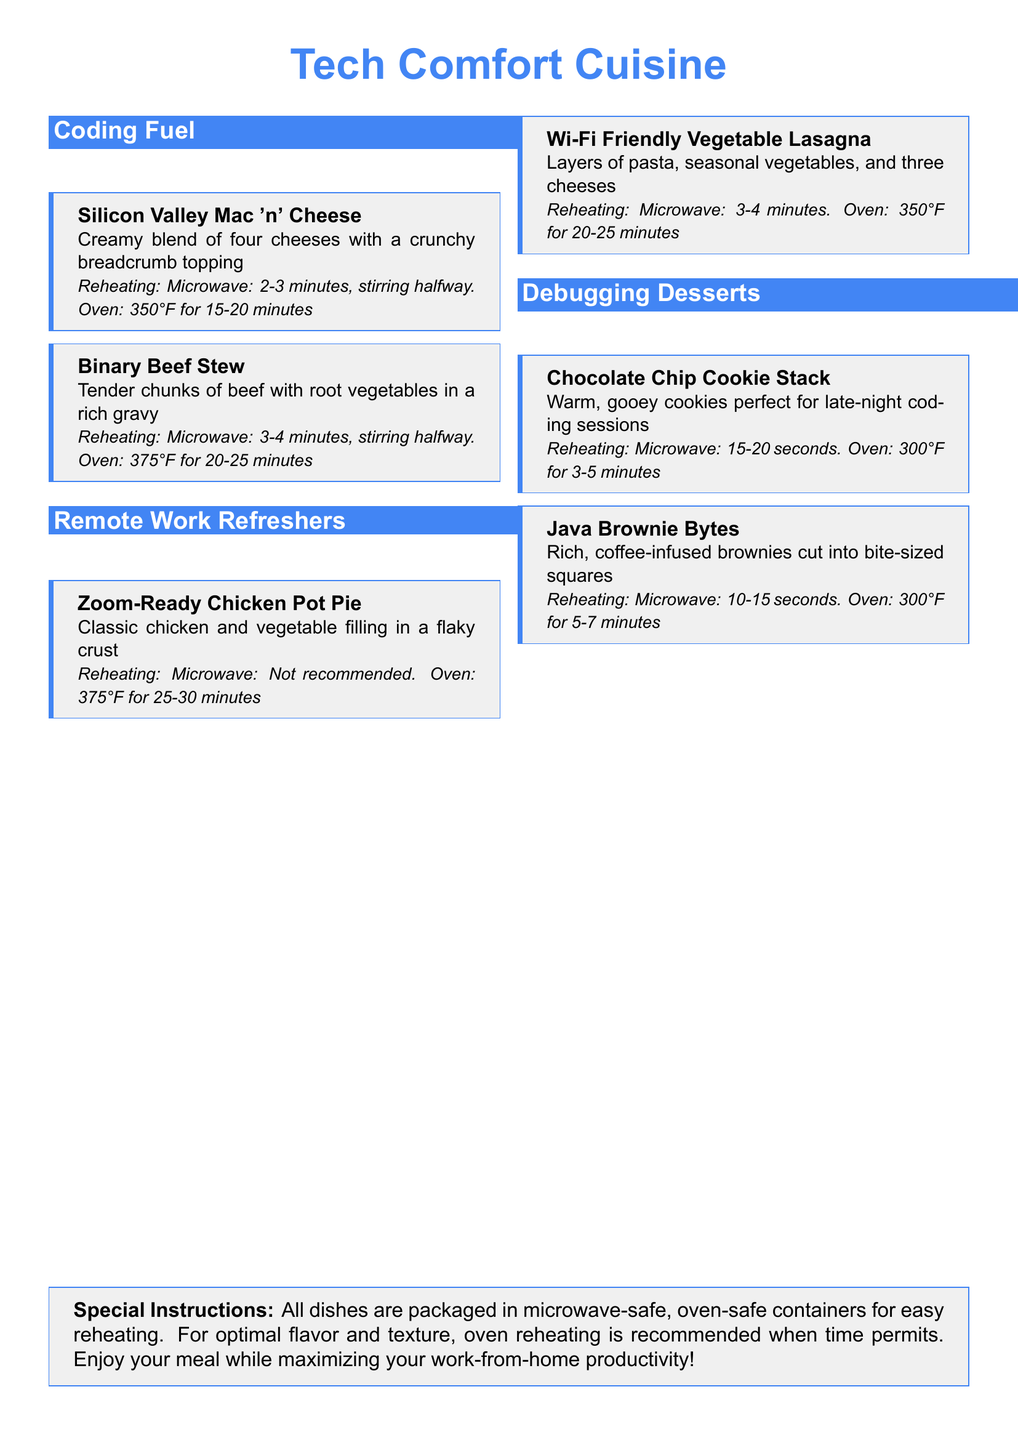What is the first dish listed under Coding Fuel? The first dish listed is "Silicon Valley Mac 'n' Cheese."
Answer: Silicon Valley Mac 'n' Cheese How long should you microwave the Binary Beef Stew? The document states to microwave for 3-4 minutes, stirring halfway.
Answer: 3-4 minutes What is the oven temperature recommended for the Zoom-Ready Chicken Pot Pie? The recommended oven temperature is 375°F.
Answer: 375°F How many types of desserts are listed in the menu? There are two types of desserts listed under Debugging Desserts.
Answer: 2 What type of dish is the Wi-Fi Friendly Vegetable Lasagna? The dish is categorized under "Remote Work Refreshers."
Answer: Remote Work Refreshers How long should the Chocolate Chip Cookie Stack be microwaved? The document notes 15-20 seconds as the reheating time in the microwave.
Answer: 15-20 seconds Which dish is specifically not recommended for microwave reheating? The dish that is not recommended for microwave reheating is the "Zoom-Ready Chicken Pot Pie."
Answer: Zoom-Ready Chicken Pot Pie What does the special instruction indicate about the packaging? It states that all dishes are packaged in microwave-safe, oven-safe containers.
Answer: Microwave-safe, oven-safe containers 